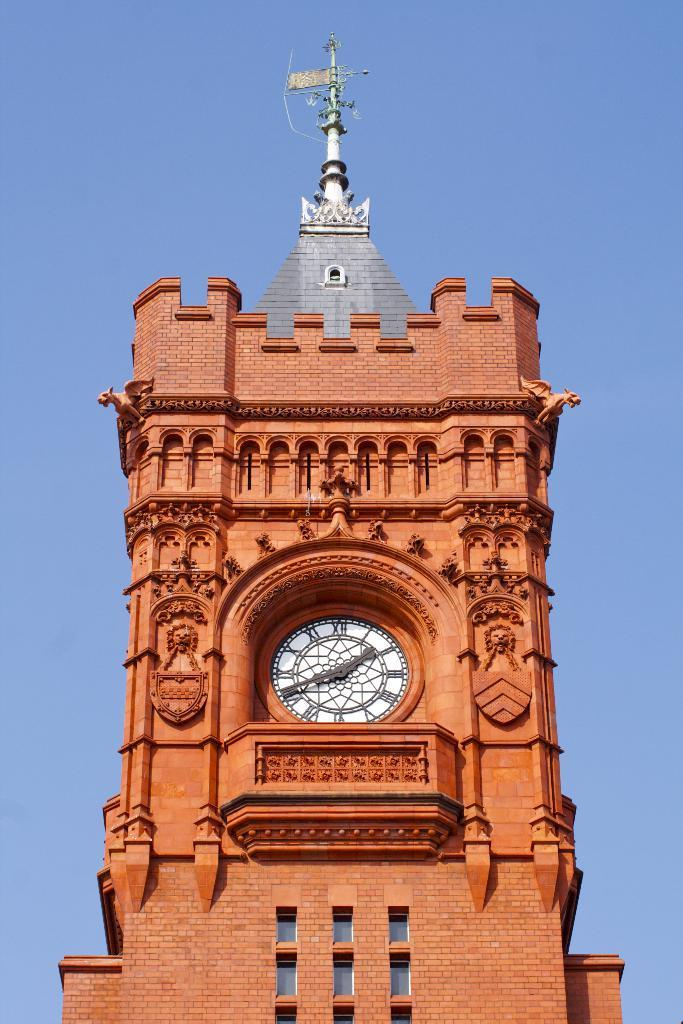What is the main structure in the image? There is a clock tower in the image. Where is the clock tower located in the image? The clock tower is in the middle of the image. What is present above the clock tower? There is an antenna above the clock tower. What can be seen in the background of the image? The sky is visible in the image. How many pigs are standing in the shade near the clock tower in the image? There are no pigs present in the image, and therefore no pigs can be found standing in the shade. 